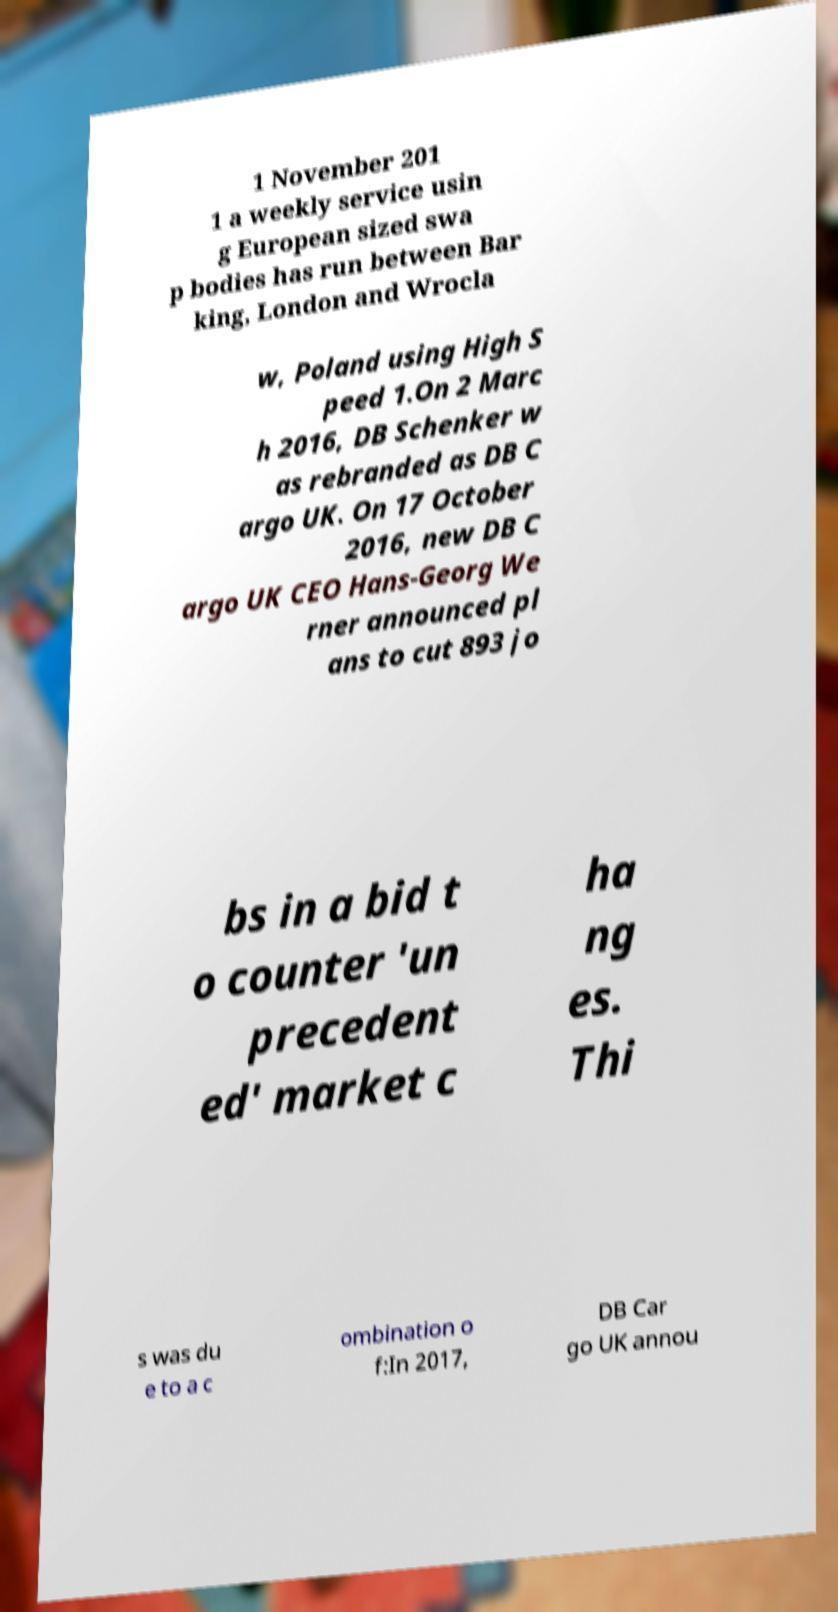What messages or text are displayed in this image? I need them in a readable, typed format. 1 November 201 1 a weekly service usin g European sized swa p bodies has run between Bar king, London and Wrocla w, Poland using High S peed 1.On 2 Marc h 2016, DB Schenker w as rebranded as DB C argo UK. On 17 October 2016, new DB C argo UK CEO Hans-Georg We rner announced pl ans to cut 893 jo bs in a bid t o counter 'un precedent ed' market c ha ng es. Thi s was du e to a c ombination o f:In 2017, DB Car go UK annou 